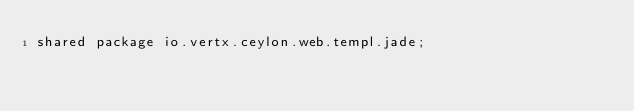<code> <loc_0><loc_0><loc_500><loc_500><_Ceylon_>shared package io.vertx.ceylon.web.templ.jade;</code> 